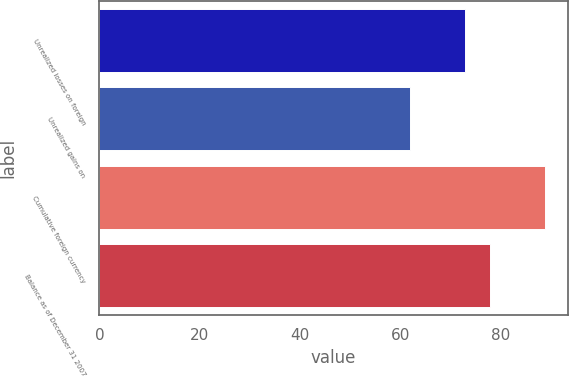<chart> <loc_0><loc_0><loc_500><loc_500><bar_chart><fcel>Unrealized losses on foreign<fcel>Unrealized gains on<fcel>Cumulative foreign currency<fcel>Balance as of December 31 2007<nl><fcel>73<fcel>62<fcel>89<fcel>78<nl></chart> 